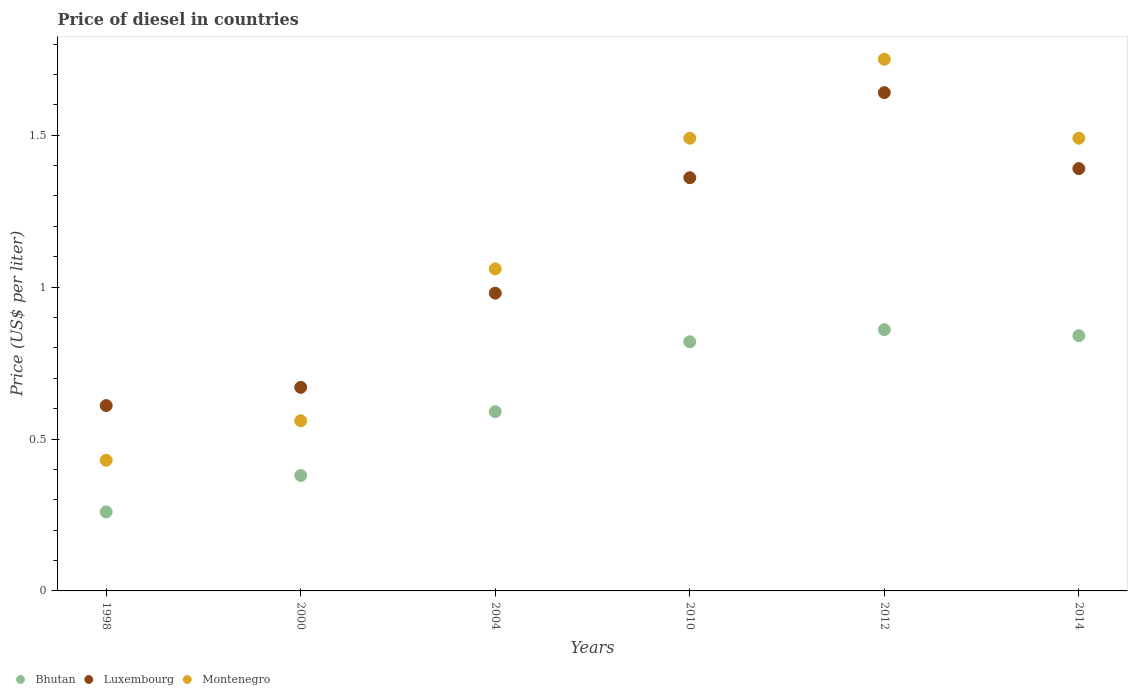How many different coloured dotlines are there?
Ensure brevity in your answer.  3. What is the price of diesel in Bhutan in 2004?
Offer a very short reply. 0.59. Across all years, what is the maximum price of diesel in Bhutan?
Make the answer very short. 0.86. Across all years, what is the minimum price of diesel in Montenegro?
Your answer should be compact. 0.43. In which year was the price of diesel in Bhutan minimum?
Your response must be concise. 1998. What is the total price of diesel in Luxembourg in the graph?
Your response must be concise. 6.65. What is the difference between the price of diesel in Bhutan in 2000 and that in 2014?
Offer a very short reply. -0.46. What is the difference between the price of diesel in Luxembourg in 1998 and the price of diesel in Bhutan in 2010?
Give a very brief answer. -0.21. What is the average price of diesel in Luxembourg per year?
Your response must be concise. 1.11. In the year 2010, what is the difference between the price of diesel in Luxembourg and price of diesel in Montenegro?
Keep it short and to the point. -0.13. In how many years, is the price of diesel in Luxembourg greater than 1.7 US$?
Provide a short and direct response. 0. What is the ratio of the price of diesel in Montenegro in 1998 to that in 2004?
Make the answer very short. 0.41. Is the price of diesel in Montenegro in 2004 less than that in 2012?
Make the answer very short. Yes. What is the difference between the highest and the second highest price of diesel in Montenegro?
Offer a very short reply. 0.26. What is the difference between the highest and the lowest price of diesel in Montenegro?
Give a very brief answer. 1.32. Is the sum of the price of diesel in Montenegro in 1998 and 2000 greater than the maximum price of diesel in Bhutan across all years?
Keep it short and to the point. Yes. Is it the case that in every year, the sum of the price of diesel in Bhutan and price of diesel in Montenegro  is greater than the price of diesel in Luxembourg?
Make the answer very short. Yes. How many dotlines are there?
Offer a terse response. 3. How many years are there in the graph?
Your answer should be compact. 6. What is the difference between two consecutive major ticks on the Y-axis?
Offer a very short reply. 0.5. How many legend labels are there?
Offer a terse response. 3. How are the legend labels stacked?
Offer a very short reply. Horizontal. What is the title of the graph?
Give a very brief answer. Price of diesel in countries. What is the label or title of the X-axis?
Provide a short and direct response. Years. What is the label or title of the Y-axis?
Ensure brevity in your answer.  Price (US$ per liter). What is the Price (US$ per liter) in Bhutan in 1998?
Your answer should be very brief. 0.26. What is the Price (US$ per liter) in Luxembourg in 1998?
Your answer should be compact. 0.61. What is the Price (US$ per liter) in Montenegro in 1998?
Ensure brevity in your answer.  0.43. What is the Price (US$ per liter) of Bhutan in 2000?
Give a very brief answer. 0.38. What is the Price (US$ per liter) of Luxembourg in 2000?
Make the answer very short. 0.67. What is the Price (US$ per liter) of Montenegro in 2000?
Ensure brevity in your answer.  0.56. What is the Price (US$ per liter) of Bhutan in 2004?
Your answer should be very brief. 0.59. What is the Price (US$ per liter) of Montenegro in 2004?
Offer a terse response. 1.06. What is the Price (US$ per liter) in Bhutan in 2010?
Provide a succinct answer. 0.82. What is the Price (US$ per liter) in Luxembourg in 2010?
Make the answer very short. 1.36. What is the Price (US$ per liter) of Montenegro in 2010?
Your answer should be very brief. 1.49. What is the Price (US$ per liter) in Bhutan in 2012?
Ensure brevity in your answer.  0.86. What is the Price (US$ per liter) of Luxembourg in 2012?
Your answer should be compact. 1.64. What is the Price (US$ per liter) in Bhutan in 2014?
Your answer should be compact. 0.84. What is the Price (US$ per liter) of Luxembourg in 2014?
Offer a very short reply. 1.39. What is the Price (US$ per liter) in Montenegro in 2014?
Provide a succinct answer. 1.49. Across all years, what is the maximum Price (US$ per liter) in Bhutan?
Give a very brief answer. 0.86. Across all years, what is the maximum Price (US$ per liter) in Luxembourg?
Ensure brevity in your answer.  1.64. Across all years, what is the maximum Price (US$ per liter) of Montenegro?
Your answer should be very brief. 1.75. Across all years, what is the minimum Price (US$ per liter) of Bhutan?
Your response must be concise. 0.26. Across all years, what is the minimum Price (US$ per liter) in Luxembourg?
Your answer should be very brief. 0.61. Across all years, what is the minimum Price (US$ per liter) of Montenegro?
Offer a terse response. 0.43. What is the total Price (US$ per liter) in Bhutan in the graph?
Make the answer very short. 3.75. What is the total Price (US$ per liter) of Luxembourg in the graph?
Give a very brief answer. 6.65. What is the total Price (US$ per liter) in Montenegro in the graph?
Your answer should be compact. 6.78. What is the difference between the Price (US$ per liter) in Bhutan in 1998 and that in 2000?
Ensure brevity in your answer.  -0.12. What is the difference between the Price (US$ per liter) in Luxembourg in 1998 and that in 2000?
Your answer should be compact. -0.06. What is the difference between the Price (US$ per liter) in Montenegro in 1998 and that in 2000?
Provide a succinct answer. -0.13. What is the difference between the Price (US$ per liter) of Bhutan in 1998 and that in 2004?
Give a very brief answer. -0.33. What is the difference between the Price (US$ per liter) in Luxembourg in 1998 and that in 2004?
Give a very brief answer. -0.37. What is the difference between the Price (US$ per liter) in Montenegro in 1998 and that in 2004?
Your response must be concise. -0.63. What is the difference between the Price (US$ per liter) of Bhutan in 1998 and that in 2010?
Make the answer very short. -0.56. What is the difference between the Price (US$ per liter) in Luxembourg in 1998 and that in 2010?
Ensure brevity in your answer.  -0.75. What is the difference between the Price (US$ per liter) of Montenegro in 1998 and that in 2010?
Offer a terse response. -1.06. What is the difference between the Price (US$ per liter) of Bhutan in 1998 and that in 2012?
Give a very brief answer. -0.6. What is the difference between the Price (US$ per liter) in Luxembourg in 1998 and that in 2012?
Your answer should be very brief. -1.03. What is the difference between the Price (US$ per liter) in Montenegro in 1998 and that in 2012?
Offer a terse response. -1.32. What is the difference between the Price (US$ per liter) in Bhutan in 1998 and that in 2014?
Provide a succinct answer. -0.58. What is the difference between the Price (US$ per liter) of Luxembourg in 1998 and that in 2014?
Your response must be concise. -0.78. What is the difference between the Price (US$ per liter) of Montenegro in 1998 and that in 2014?
Your answer should be very brief. -1.06. What is the difference between the Price (US$ per liter) in Bhutan in 2000 and that in 2004?
Provide a succinct answer. -0.21. What is the difference between the Price (US$ per liter) in Luxembourg in 2000 and that in 2004?
Your answer should be compact. -0.31. What is the difference between the Price (US$ per liter) of Montenegro in 2000 and that in 2004?
Give a very brief answer. -0.5. What is the difference between the Price (US$ per liter) in Bhutan in 2000 and that in 2010?
Your answer should be very brief. -0.44. What is the difference between the Price (US$ per liter) in Luxembourg in 2000 and that in 2010?
Your response must be concise. -0.69. What is the difference between the Price (US$ per liter) in Montenegro in 2000 and that in 2010?
Make the answer very short. -0.93. What is the difference between the Price (US$ per liter) of Bhutan in 2000 and that in 2012?
Offer a very short reply. -0.48. What is the difference between the Price (US$ per liter) of Luxembourg in 2000 and that in 2012?
Your response must be concise. -0.97. What is the difference between the Price (US$ per liter) in Montenegro in 2000 and that in 2012?
Keep it short and to the point. -1.19. What is the difference between the Price (US$ per liter) in Bhutan in 2000 and that in 2014?
Provide a short and direct response. -0.46. What is the difference between the Price (US$ per liter) in Luxembourg in 2000 and that in 2014?
Give a very brief answer. -0.72. What is the difference between the Price (US$ per liter) of Montenegro in 2000 and that in 2014?
Offer a very short reply. -0.93. What is the difference between the Price (US$ per liter) in Bhutan in 2004 and that in 2010?
Your response must be concise. -0.23. What is the difference between the Price (US$ per liter) of Luxembourg in 2004 and that in 2010?
Provide a succinct answer. -0.38. What is the difference between the Price (US$ per liter) in Montenegro in 2004 and that in 2010?
Your response must be concise. -0.43. What is the difference between the Price (US$ per liter) in Bhutan in 2004 and that in 2012?
Your answer should be compact. -0.27. What is the difference between the Price (US$ per liter) of Luxembourg in 2004 and that in 2012?
Make the answer very short. -0.66. What is the difference between the Price (US$ per liter) in Montenegro in 2004 and that in 2012?
Offer a very short reply. -0.69. What is the difference between the Price (US$ per liter) in Luxembourg in 2004 and that in 2014?
Provide a short and direct response. -0.41. What is the difference between the Price (US$ per liter) of Montenegro in 2004 and that in 2014?
Provide a succinct answer. -0.43. What is the difference between the Price (US$ per liter) in Bhutan in 2010 and that in 2012?
Provide a succinct answer. -0.04. What is the difference between the Price (US$ per liter) in Luxembourg in 2010 and that in 2012?
Make the answer very short. -0.28. What is the difference between the Price (US$ per liter) in Montenegro in 2010 and that in 2012?
Your answer should be very brief. -0.26. What is the difference between the Price (US$ per liter) of Bhutan in 2010 and that in 2014?
Offer a terse response. -0.02. What is the difference between the Price (US$ per liter) in Luxembourg in 2010 and that in 2014?
Your response must be concise. -0.03. What is the difference between the Price (US$ per liter) of Montenegro in 2010 and that in 2014?
Your answer should be compact. 0. What is the difference between the Price (US$ per liter) of Montenegro in 2012 and that in 2014?
Ensure brevity in your answer.  0.26. What is the difference between the Price (US$ per liter) of Bhutan in 1998 and the Price (US$ per liter) of Luxembourg in 2000?
Provide a succinct answer. -0.41. What is the difference between the Price (US$ per liter) in Bhutan in 1998 and the Price (US$ per liter) in Luxembourg in 2004?
Provide a succinct answer. -0.72. What is the difference between the Price (US$ per liter) in Bhutan in 1998 and the Price (US$ per liter) in Montenegro in 2004?
Make the answer very short. -0.8. What is the difference between the Price (US$ per liter) of Luxembourg in 1998 and the Price (US$ per liter) of Montenegro in 2004?
Your answer should be very brief. -0.45. What is the difference between the Price (US$ per liter) of Bhutan in 1998 and the Price (US$ per liter) of Montenegro in 2010?
Provide a short and direct response. -1.23. What is the difference between the Price (US$ per liter) of Luxembourg in 1998 and the Price (US$ per liter) of Montenegro in 2010?
Give a very brief answer. -0.88. What is the difference between the Price (US$ per liter) in Bhutan in 1998 and the Price (US$ per liter) in Luxembourg in 2012?
Your answer should be very brief. -1.38. What is the difference between the Price (US$ per liter) of Bhutan in 1998 and the Price (US$ per liter) of Montenegro in 2012?
Give a very brief answer. -1.49. What is the difference between the Price (US$ per liter) of Luxembourg in 1998 and the Price (US$ per liter) of Montenegro in 2012?
Ensure brevity in your answer.  -1.14. What is the difference between the Price (US$ per liter) in Bhutan in 1998 and the Price (US$ per liter) in Luxembourg in 2014?
Offer a very short reply. -1.13. What is the difference between the Price (US$ per liter) in Bhutan in 1998 and the Price (US$ per liter) in Montenegro in 2014?
Ensure brevity in your answer.  -1.23. What is the difference between the Price (US$ per liter) of Luxembourg in 1998 and the Price (US$ per liter) of Montenegro in 2014?
Make the answer very short. -0.88. What is the difference between the Price (US$ per liter) of Bhutan in 2000 and the Price (US$ per liter) of Luxembourg in 2004?
Your response must be concise. -0.6. What is the difference between the Price (US$ per liter) in Bhutan in 2000 and the Price (US$ per liter) in Montenegro in 2004?
Offer a terse response. -0.68. What is the difference between the Price (US$ per liter) of Luxembourg in 2000 and the Price (US$ per liter) of Montenegro in 2004?
Give a very brief answer. -0.39. What is the difference between the Price (US$ per liter) in Bhutan in 2000 and the Price (US$ per liter) in Luxembourg in 2010?
Provide a short and direct response. -0.98. What is the difference between the Price (US$ per liter) in Bhutan in 2000 and the Price (US$ per liter) in Montenegro in 2010?
Give a very brief answer. -1.11. What is the difference between the Price (US$ per liter) in Luxembourg in 2000 and the Price (US$ per liter) in Montenegro in 2010?
Make the answer very short. -0.82. What is the difference between the Price (US$ per liter) of Bhutan in 2000 and the Price (US$ per liter) of Luxembourg in 2012?
Offer a very short reply. -1.26. What is the difference between the Price (US$ per liter) in Bhutan in 2000 and the Price (US$ per liter) in Montenegro in 2012?
Provide a short and direct response. -1.37. What is the difference between the Price (US$ per liter) in Luxembourg in 2000 and the Price (US$ per liter) in Montenegro in 2012?
Make the answer very short. -1.08. What is the difference between the Price (US$ per liter) in Bhutan in 2000 and the Price (US$ per liter) in Luxembourg in 2014?
Offer a terse response. -1.01. What is the difference between the Price (US$ per liter) of Bhutan in 2000 and the Price (US$ per liter) of Montenegro in 2014?
Your answer should be compact. -1.11. What is the difference between the Price (US$ per liter) in Luxembourg in 2000 and the Price (US$ per liter) in Montenegro in 2014?
Keep it short and to the point. -0.82. What is the difference between the Price (US$ per liter) of Bhutan in 2004 and the Price (US$ per liter) of Luxembourg in 2010?
Keep it short and to the point. -0.77. What is the difference between the Price (US$ per liter) of Bhutan in 2004 and the Price (US$ per liter) of Montenegro in 2010?
Your answer should be compact. -0.9. What is the difference between the Price (US$ per liter) of Luxembourg in 2004 and the Price (US$ per liter) of Montenegro in 2010?
Give a very brief answer. -0.51. What is the difference between the Price (US$ per liter) in Bhutan in 2004 and the Price (US$ per liter) in Luxembourg in 2012?
Ensure brevity in your answer.  -1.05. What is the difference between the Price (US$ per liter) of Bhutan in 2004 and the Price (US$ per liter) of Montenegro in 2012?
Provide a succinct answer. -1.16. What is the difference between the Price (US$ per liter) in Luxembourg in 2004 and the Price (US$ per liter) in Montenegro in 2012?
Make the answer very short. -0.77. What is the difference between the Price (US$ per liter) of Bhutan in 2004 and the Price (US$ per liter) of Luxembourg in 2014?
Provide a short and direct response. -0.8. What is the difference between the Price (US$ per liter) in Luxembourg in 2004 and the Price (US$ per liter) in Montenegro in 2014?
Offer a terse response. -0.51. What is the difference between the Price (US$ per liter) in Bhutan in 2010 and the Price (US$ per liter) in Luxembourg in 2012?
Give a very brief answer. -0.82. What is the difference between the Price (US$ per liter) of Bhutan in 2010 and the Price (US$ per liter) of Montenegro in 2012?
Offer a terse response. -0.93. What is the difference between the Price (US$ per liter) in Luxembourg in 2010 and the Price (US$ per liter) in Montenegro in 2012?
Ensure brevity in your answer.  -0.39. What is the difference between the Price (US$ per liter) in Bhutan in 2010 and the Price (US$ per liter) in Luxembourg in 2014?
Your response must be concise. -0.57. What is the difference between the Price (US$ per liter) of Bhutan in 2010 and the Price (US$ per liter) of Montenegro in 2014?
Give a very brief answer. -0.67. What is the difference between the Price (US$ per liter) in Luxembourg in 2010 and the Price (US$ per liter) in Montenegro in 2014?
Offer a terse response. -0.13. What is the difference between the Price (US$ per liter) of Bhutan in 2012 and the Price (US$ per liter) of Luxembourg in 2014?
Give a very brief answer. -0.53. What is the difference between the Price (US$ per liter) of Bhutan in 2012 and the Price (US$ per liter) of Montenegro in 2014?
Your response must be concise. -0.63. What is the difference between the Price (US$ per liter) of Luxembourg in 2012 and the Price (US$ per liter) of Montenegro in 2014?
Keep it short and to the point. 0.15. What is the average Price (US$ per liter) of Luxembourg per year?
Offer a terse response. 1.11. What is the average Price (US$ per liter) in Montenegro per year?
Make the answer very short. 1.13. In the year 1998, what is the difference between the Price (US$ per liter) in Bhutan and Price (US$ per liter) in Luxembourg?
Provide a succinct answer. -0.35. In the year 1998, what is the difference between the Price (US$ per liter) in Bhutan and Price (US$ per liter) in Montenegro?
Your answer should be very brief. -0.17. In the year 1998, what is the difference between the Price (US$ per liter) of Luxembourg and Price (US$ per liter) of Montenegro?
Make the answer very short. 0.18. In the year 2000, what is the difference between the Price (US$ per liter) in Bhutan and Price (US$ per liter) in Luxembourg?
Give a very brief answer. -0.29. In the year 2000, what is the difference between the Price (US$ per liter) of Bhutan and Price (US$ per liter) of Montenegro?
Your response must be concise. -0.18. In the year 2000, what is the difference between the Price (US$ per liter) in Luxembourg and Price (US$ per liter) in Montenegro?
Keep it short and to the point. 0.11. In the year 2004, what is the difference between the Price (US$ per liter) of Bhutan and Price (US$ per liter) of Luxembourg?
Your response must be concise. -0.39. In the year 2004, what is the difference between the Price (US$ per liter) of Bhutan and Price (US$ per liter) of Montenegro?
Make the answer very short. -0.47. In the year 2004, what is the difference between the Price (US$ per liter) of Luxembourg and Price (US$ per liter) of Montenegro?
Your answer should be very brief. -0.08. In the year 2010, what is the difference between the Price (US$ per liter) in Bhutan and Price (US$ per liter) in Luxembourg?
Offer a terse response. -0.54. In the year 2010, what is the difference between the Price (US$ per liter) in Bhutan and Price (US$ per liter) in Montenegro?
Ensure brevity in your answer.  -0.67. In the year 2010, what is the difference between the Price (US$ per liter) in Luxembourg and Price (US$ per liter) in Montenegro?
Your response must be concise. -0.13. In the year 2012, what is the difference between the Price (US$ per liter) in Bhutan and Price (US$ per liter) in Luxembourg?
Keep it short and to the point. -0.78. In the year 2012, what is the difference between the Price (US$ per liter) of Bhutan and Price (US$ per liter) of Montenegro?
Offer a very short reply. -0.89. In the year 2012, what is the difference between the Price (US$ per liter) of Luxembourg and Price (US$ per liter) of Montenegro?
Provide a succinct answer. -0.11. In the year 2014, what is the difference between the Price (US$ per liter) in Bhutan and Price (US$ per liter) in Luxembourg?
Ensure brevity in your answer.  -0.55. In the year 2014, what is the difference between the Price (US$ per liter) of Bhutan and Price (US$ per liter) of Montenegro?
Make the answer very short. -0.65. In the year 2014, what is the difference between the Price (US$ per liter) of Luxembourg and Price (US$ per liter) of Montenegro?
Provide a short and direct response. -0.1. What is the ratio of the Price (US$ per liter) in Bhutan in 1998 to that in 2000?
Make the answer very short. 0.68. What is the ratio of the Price (US$ per liter) in Luxembourg in 1998 to that in 2000?
Offer a very short reply. 0.91. What is the ratio of the Price (US$ per liter) of Montenegro in 1998 to that in 2000?
Your answer should be very brief. 0.77. What is the ratio of the Price (US$ per liter) in Bhutan in 1998 to that in 2004?
Your answer should be compact. 0.44. What is the ratio of the Price (US$ per liter) of Luxembourg in 1998 to that in 2004?
Make the answer very short. 0.62. What is the ratio of the Price (US$ per liter) of Montenegro in 1998 to that in 2004?
Ensure brevity in your answer.  0.41. What is the ratio of the Price (US$ per liter) of Bhutan in 1998 to that in 2010?
Make the answer very short. 0.32. What is the ratio of the Price (US$ per liter) of Luxembourg in 1998 to that in 2010?
Ensure brevity in your answer.  0.45. What is the ratio of the Price (US$ per liter) in Montenegro in 1998 to that in 2010?
Offer a very short reply. 0.29. What is the ratio of the Price (US$ per liter) of Bhutan in 1998 to that in 2012?
Give a very brief answer. 0.3. What is the ratio of the Price (US$ per liter) in Luxembourg in 1998 to that in 2012?
Give a very brief answer. 0.37. What is the ratio of the Price (US$ per liter) of Montenegro in 1998 to that in 2012?
Make the answer very short. 0.25. What is the ratio of the Price (US$ per liter) in Bhutan in 1998 to that in 2014?
Your answer should be very brief. 0.31. What is the ratio of the Price (US$ per liter) of Luxembourg in 1998 to that in 2014?
Keep it short and to the point. 0.44. What is the ratio of the Price (US$ per liter) in Montenegro in 1998 to that in 2014?
Keep it short and to the point. 0.29. What is the ratio of the Price (US$ per liter) of Bhutan in 2000 to that in 2004?
Give a very brief answer. 0.64. What is the ratio of the Price (US$ per liter) in Luxembourg in 2000 to that in 2004?
Offer a terse response. 0.68. What is the ratio of the Price (US$ per liter) in Montenegro in 2000 to that in 2004?
Give a very brief answer. 0.53. What is the ratio of the Price (US$ per liter) in Bhutan in 2000 to that in 2010?
Provide a succinct answer. 0.46. What is the ratio of the Price (US$ per liter) of Luxembourg in 2000 to that in 2010?
Your answer should be compact. 0.49. What is the ratio of the Price (US$ per liter) of Montenegro in 2000 to that in 2010?
Your answer should be very brief. 0.38. What is the ratio of the Price (US$ per liter) of Bhutan in 2000 to that in 2012?
Provide a short and direct response. 0.44. What is the ratio of the Price (US$ per liter) in Luxembourg in 2000 to that in 2012?
Provide a succinct answer. 0.41. What is the ratio of the Price (US$ per liter) in Montenegro in 2000 to that in 2012?
Make the answer very short. 0.32. What is the ratio of the Price (US$ per liter) of Bhutan in 2000 to that in 2014?
Keep it short and to the point. 0.45. What is the ratio of the Price (US$ per liter) in Luxembourg in 2000 to that in 2014?
Offer a very short reply. 0.48. What is the ratio of the Price (US$ per liter) of Montenegro in 2000 to that in 2014?
Your answer should be compact. 0.38. What is the ratio of the Price (US$ per liter) in Bhutan in 2004 to that in 2010?
Ensure brevity in your answer.  0.72. What is the ratio of the Price (US$ per liter) in Luxembourg in 2004 to that in 2010?
Offer a terse response. 0.72. What is the ratio of the Price (US$ per liter) in Montenegro in 2004 to that in 2010?
Make the answer very short. 0.71. What is the ratio of the Price (US$ per liter) of Bhutan in 2004 to that in 2012?
Provide a succinct answer. 0.69. What is the ratio of the Price (US$ per liter) of Luxembourg in 2004 to that in 2012?
Your response must be concise. 0.6. What is the ratio of the Price (US$ per liter) in Montenegro in 2004 to that in 2012?
Your answer should be very brief. 0.61. What is the ratio of the Price (US$ per liter) of Bhutan in 2004 to that in 2014?
Provide a short and direct response. 0.7. What is the ratio of the Price (US$ per liter) in Luxembourg in 2004 to that in 2014?
Your answer should be very brief. 0.7. What is the ratio of the Price (US$ per liter) of Montenegro in 2004 to that in 2014?
Make the answer very short. 0.71. What is the ratio of the Price (US$ per liter) in Bhutan in 2010 to that in 2012?
Offer a terse response. 0.95. What is the ratio of the Price (US$ per liter) in Luxembourg in 2010 to that in 2012?
Your answer should be compact. 0.83. What is the ratio of the Price (US$ per liter) of Montenegro in 2010 to that in 2012?
Your response must be concise. 0.85. What is the ratio of the Price (US$ per liter) of Bhutan in 2010 to that in 2014?
Ensure brevity in your answer.  0.98. What is the ratio of the Price (US$ per liter) in Luxembourg in 2010 to that in 2014?
Your answer should be compact. 0.98. What is the ratio of the Price (US$ per liter) of Bhutan in 2012 to that in 2014?
Your answer should be very brief. 1.02. What is the ratio of the Price (US$ per liter) of Luxembourg in 2012 to that in 2014?
Make the answer very short. 1.18. What is the ratio of the Price (US$ per liter) of Montenegro in 2012 to that in 2014?
Give a very brief answer. 1.17. What is the difference between the highest and the second highest Price (US$ per liter) in Montenegro?
Offer a very short reply. 0.26. What is the difference between the highest and the lowest Price (US$ per liter) of Bhutan?
Keep it short and to the point. 0.6. What is the difference between the highest and the lowest Price (US$ per liter) of Luxembourg?
Keep it short and to the point. 1.03. What is the difference between the highest and the lowest Price (US$ per liter) in Montenegro?
Provide a succinct answer. 1.32. 